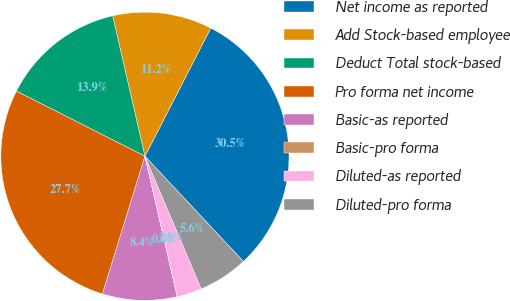Convert chart to OTSL. <chart><loc_0><loc_0><loc_500><loc_500><pie_chart><fcel>Net income as reported<fcel>Add Stock-based employee<fcel>Deduct Total stock-based<fcel>Pro forma net income<fcel>Basic-as reported<fcel>Basic-pro forma<fcel>Diluted-as reported<fcel>Diluted-pro forma<nl><fcel>30.48%<fcel>11.15%<fcel>13.94%<fcel>27.69%<fcel>8.37%<fcel>0.0%<fcel>2.79%<fcel>5.58%<nl></chart> 